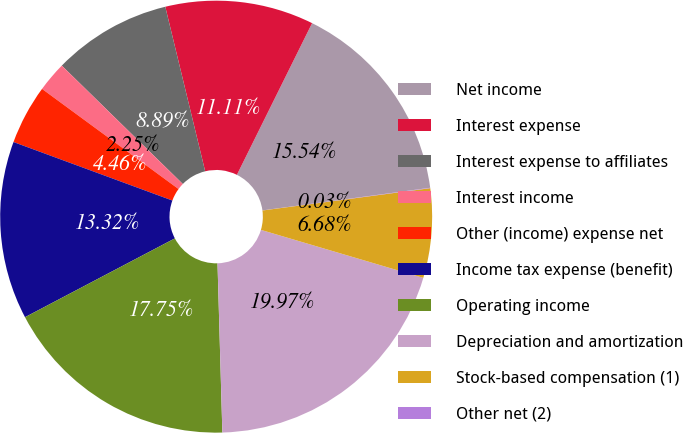<chart> <loc_0><loc_0><loc_500><loc_500><pie_chart><fcel>Net income<fcel>Interest expense<fcel>Interest expense to affiliates<fcel>Interest income<fcel>Other (income) expense net<fcel>Income tax expense (benefit)<fcel>Operating income<fcel>Depreciation and amortization<fcel>Stock-based compensation (1)<fcel>Other net (2)<nl><fcel>15.54%<fcel>11.11%<fcel>8.89%<fcel>2.25%<fcel>4.46%<fcel>13.32%<fcel>17.75%<fcel>19.97%<fcel>6.68%<fcel>0.03%<nl></chart> 